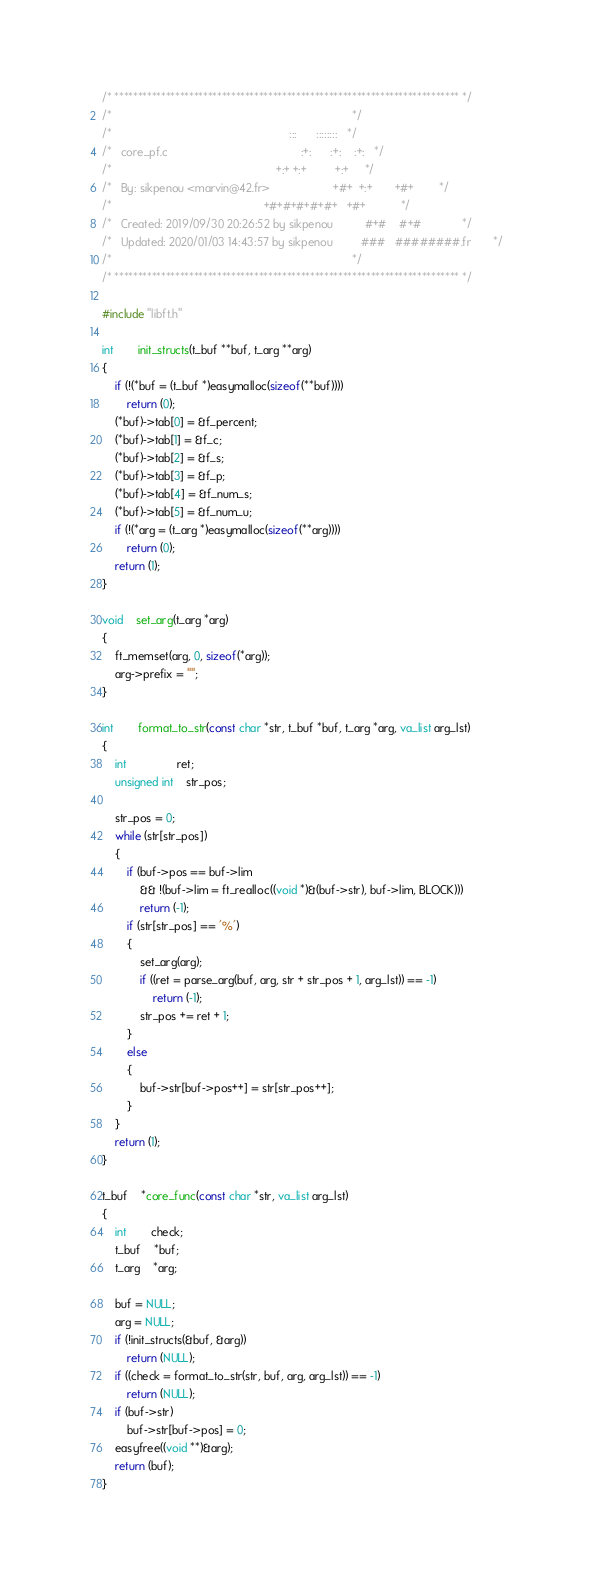<code> <loc_0><loc_0><loc_500><loc_500><_C_>/* ************************************************************************** */
/*                                                                            */
/*                                                        :::      ::::::::   */
/*   core_pf.c                                          :+:      :+:    :+:   */
/*                                                    +:+ +:+         +:+     */
/*   By: sikpenou <marvin@42.fr>                    +#+  +:+       +#+        */
/*                                                +#+#+#+#+#+   +#+           */
/*   Created: 2019/09/30 20:26:52 by sikpenou          #+#    #+#             */
/*   Updated: 2020/01/03 14:43:57 by sikpenou         ###   ########.fr       */
/*                                                                            */
/* ************************************************************************** */

#include "libft.h"

int		init_structs(t_buf **buf, t_arg **arg)
{
	if (!(*buf = (t_buf *)easymalloc(sizeof(**buf))))
		return (0);
	(*buf)->tab[0] = &f_percent;
	(*buf)->tab[1] = &f_c;
	(*buf)->tab[2] = &f_s;
	(*buf)->tab[3] = &f_p;
	(*buf)->tab[4] = &f_num_s;
	(*buf)->tab[5] = &f_num_u;
	if (!(*arg = (t_arg *)easymalloc(sizeof(**arg))))
		return (0);
	return (1);
}

void	set_arg(t_arg *arg)
{
	ft_memset(arg, 0, sizeof(*arg));
	arg->prefix = "";
}

int		format_to_str(const char *str, t_buf *buf, t_arg *arg, va_list arg_lst)
{
	int				ret;
	unsigned int	str_pos;

	str_pos = 0;
	while (str[str_pos])
	{
		if (buf->pos == buf->lim
			&& !(buf->lim = ft_realloc((void *)&(buf->str), buf->lim, BLOCK)))
			return (-1);
		if (str[str_pos] == '%')
		{
			set_arg(arg);
			if ((ret = parse_arg(buf, arg, str + str_pos + 1, arg_lst)) == -1)
				return (-1);
			str_pos += ret + 1;
		}
		else
		{
			buf->str[buf->pos++] = str[str_pos++];
		}
	}
	return (1);
}

t_buf	*core_func(const char *str, va_list arg_lst)
{
	int		check;
	t_buf	*buf;
	t_arg	*arg;

	buf = NULL;
	arg = NULL;
	if (!init_structs(&buf, &arg))
		return (NULL);
	if ((check = format_to_str(str, buf, arg, arg_lst)) == -1)
		return (NULL);
	if (buf->str)
		buf->str[buf->pos] = 0;
	easyfree((void **)&arg);
	return (buf);
}
</code> 